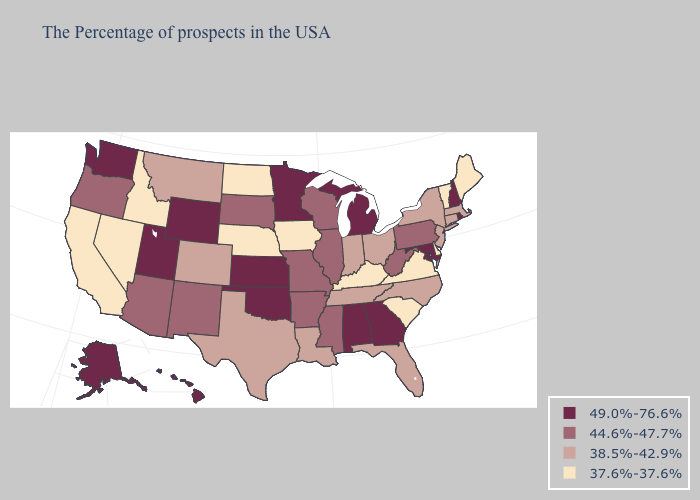What is the value of Missouri?
Keep it brief. 44.6%-47.7%. Name the states that have a value in the range 38.5%-42.9%?
Concise answer only. Massachusetts, Connecticut, New York, New Jersey, North Carolina, Ohio, Florida, Indiana, Tennessee, Louisiana, Texas, Colorado, Montana. Does the map have missing data?
Give a very brief answer. No. Name the states that have a value in the range 44.6%-47.7%?
Concise answer only. Pennsylvania, West Virginia, Wisconsin, Illinois, Mississippi, Missouri, Arkansas, South Dakota, New Mexico, Arizona, Oregon. What is the value of Maryland?
Answer briefly. 49.0%-76.6%. What is the value of North Dakota?
Concise answer only. 37.6%-37.6%. Name the states that have a value in the range 38.5%-42.9%?
Keep it brief. Massachusetts, Connecticut, New York, New Jersey, North Carolina, Ohio, Florida, Indiana, Tennessee, Louisiana, Texas, Colorado, Montana. Among the states that border Georgia , which have the highest value?
Quick response, please. Alabama. Is the legend a continuous bar?
Concise answer only. No. Which states have the highest value in the USA?
Give a very brief answer. Rhode Island, New Hampshire, Maryland, Georgia, Michigan, Alabama, Minnesota, Kansas, Oklahoma, Wyoming, Utah, Washington, Alaska, Hawaii. Among the states that border New Hampshire , does Massachusetts have the lowest value?
Short answer required. No. What is the value of North Dakota?
Short answer required. 37.6%-37.6%. Among the states that border Indiana , does Ohio have the highest value?
Quick response, please. No. What is the lowest value in the MidWest?
Quick response, please. 37.6%-37.6%. Among the states that border Tennessee , which have the highest value?
Answer briefly. Georgia, Alabama. 